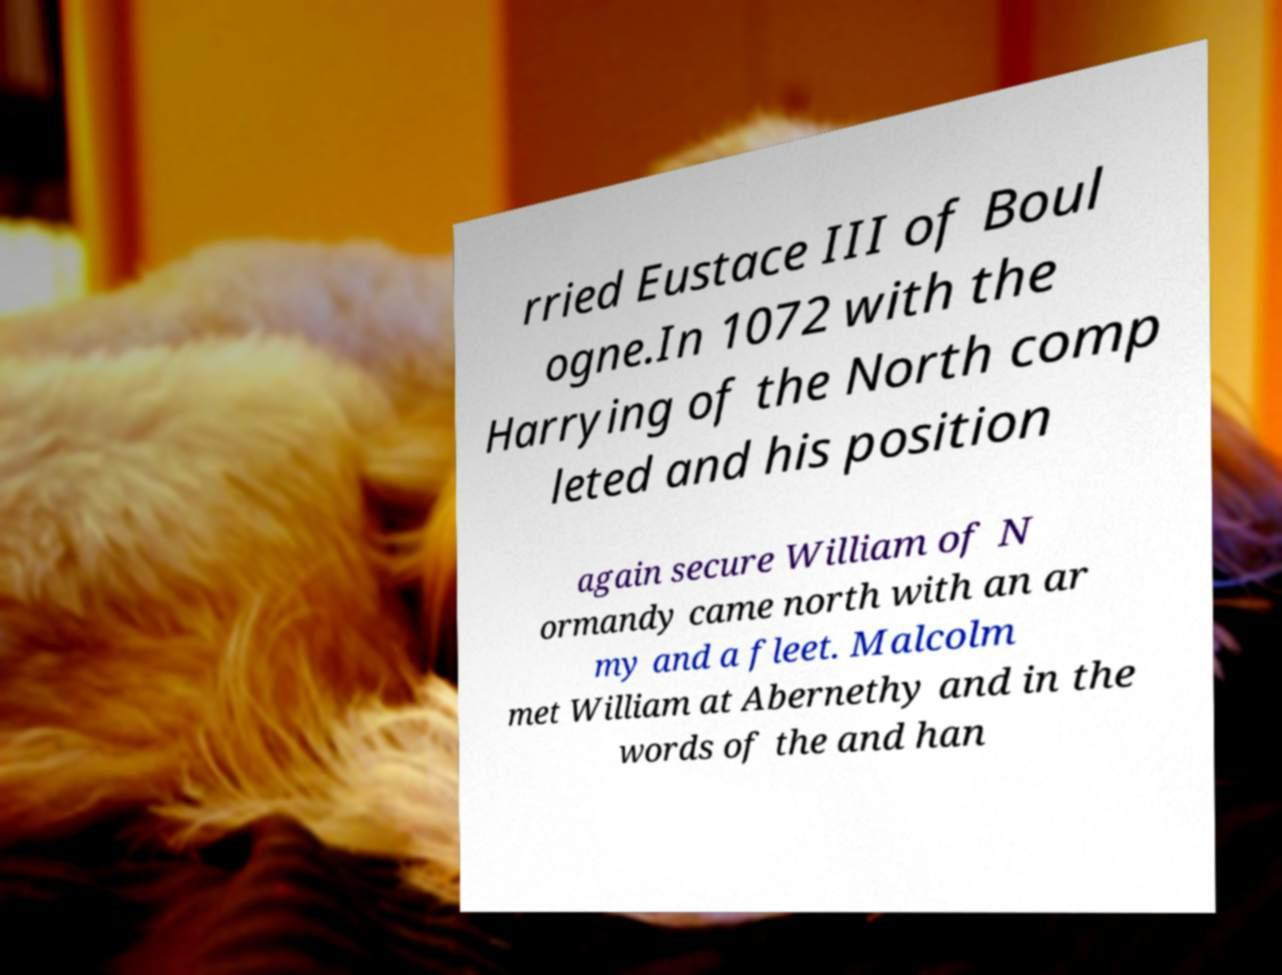Please read and relay the text visible in this image. What does it say? rried Eustace III of Boul ogne.In 1072 with the Harrying of the North comp leted and his position again secure William of N ormandy came north with an ar my and a fleet. Malcolm met William at Abernethy and in the words of the and han 